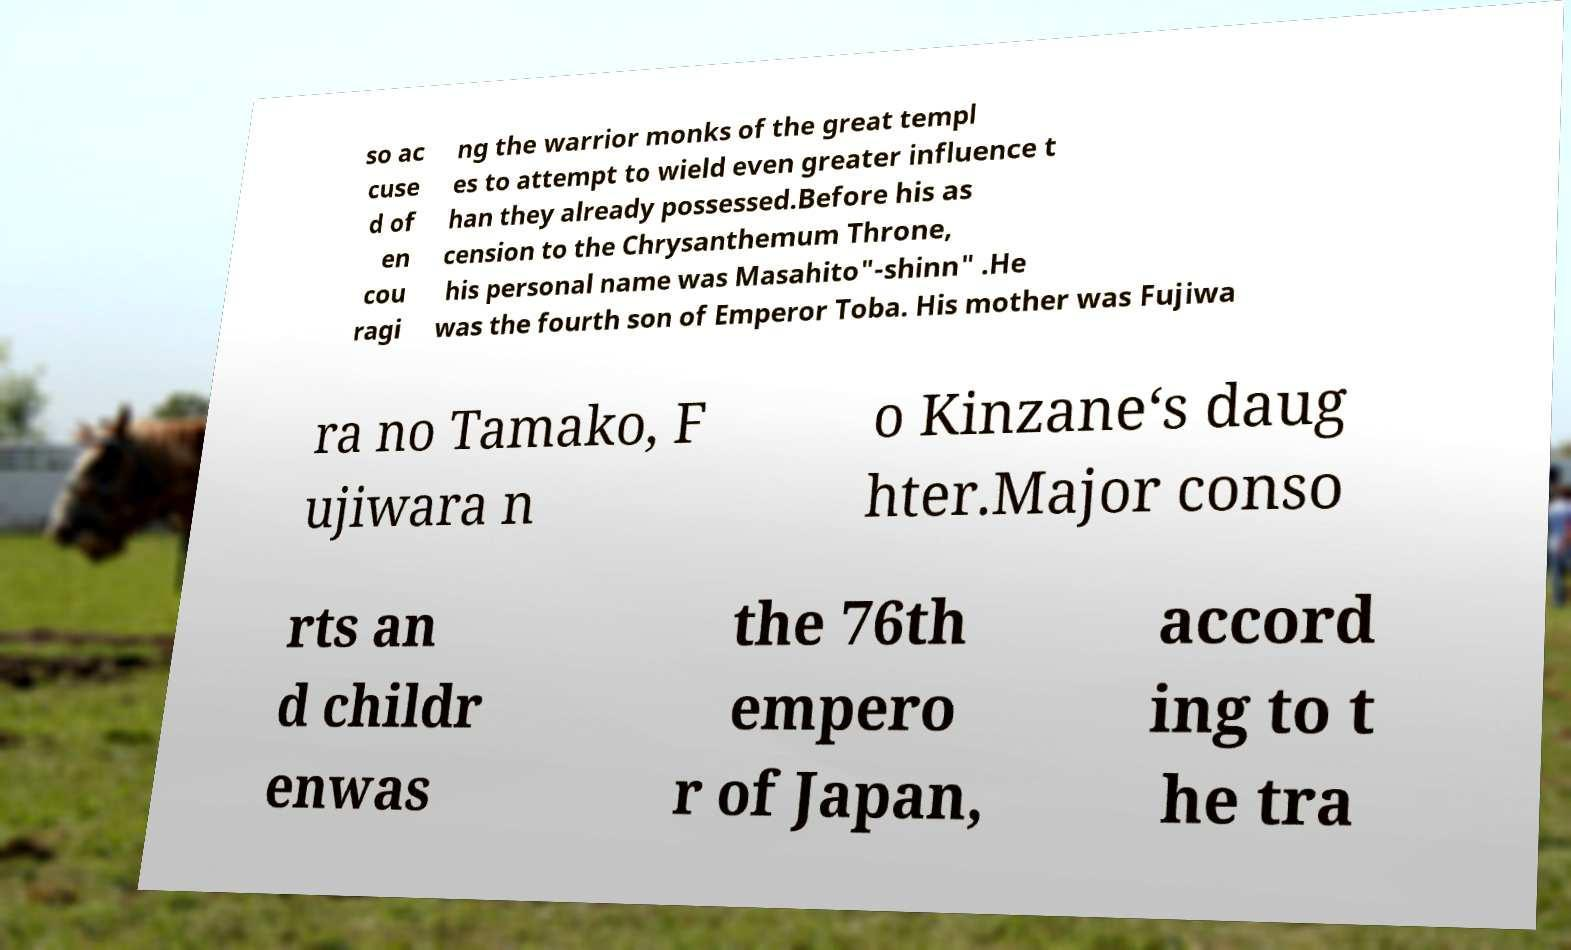Please read and relay the text visible in this image. What does it say? so ac cuse d of en cou ragi ng the warrior monks of the great templ es to attempt to wield even greater influence t han they already possessed.Before his as cension to the Chrysanthemum Throne, his personal name was Masahito"-shinn" .He was the fourth son of Emperor Toba. His mother was Fujiwa ra no Tamako, F ujiwara n o Kinzane‘s daug hter.Major conso rts an d childr enwas the 76th empero r of Japan, accord ing to t he tra 